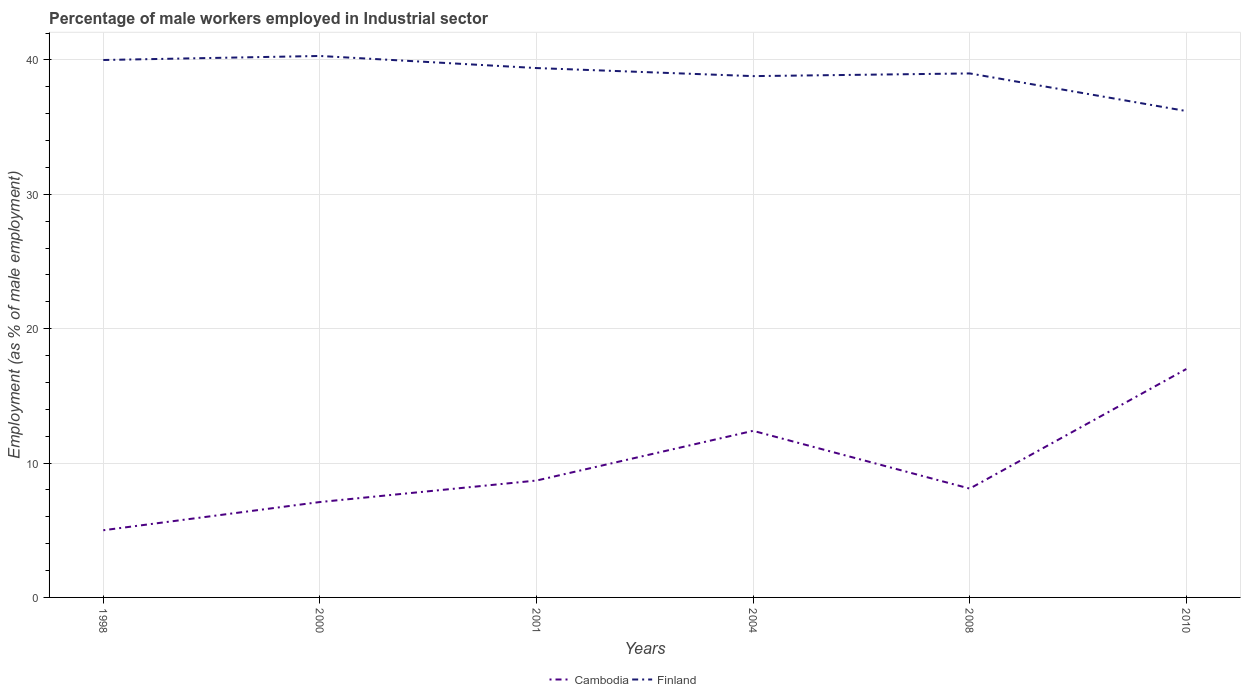Across all years, what is the maximum percentage of male workers employed in Industrial sector in Finland?
Offer a terse response. 36.2. In which year was the percentage of male workers employed in Industrial sector in Cambodia maximum?
Provide a succinct answer. 1998. What is the total percentage of male workers employed in Industrial sector in Cambodia in the graph?
Ensure brevity in your answer.  -3.7. Is the percentage of male workers employed in Industrial sector in Cambodia strictly greater than the percentage of male workers employed in Industrial sector in Finland over the years?
Provide a short and direct response. Yes. How many lines are there?
Offer a very short reply. 2. Are the values on the major ticks of Y-axis written in scientific E-notation?
Your answer should be very brief. No. Does the graph contain grids?
Offer a very short reply. Yes. How many legend labels are there?
Ensure brevity in your answer.  2. How are the legend labels stacked?
Give a very brief answer. Horizontal. What is the title of the graph?
Provide a succinct answer. Percentage of male workers employed in Industrial sector. Does "Argentina" appear as one of the legend labels in the graph?
Make the answer very short. No. What is the label or title of the X-axis?
Keep it short and to the point. Years. What is the label or title of the Y-axis?
Make the answer very short. Employment (as % of male employment). What is the Employment (as % of male employment) in Cambodia in 1998?
Give a very brief answer. 5. What is the Employment (as % of male employment) of Cambodia in 2000?
Offer a terse response. 7.1. What is the Employment (as % of male employment) in Finland in 2000?
Make the answer very short. 40.3. What is the Employment (as % of male employment) in Cambodia in 2001?
Your response must be concise. 8.7. What is the Employment (as % of male employment) in Finland in 2001?
Your answer should be very brief. 39.4. What is the Employment (as % of male employment) in Cambodia in 2004?
Provide a short and direct response. 12.4. What is the Employment (as % of male employment) in Finland in 2004?
Ensure brevity in your answer.  38.8. What is the Employment (as % of male employment) of Cambodia in 2008?
Offer a very short reply. 8.1. What is the Employment (as % of male employment) in Finland in 2008?
Keep it short and to the point. 39. What is the Employment (as % of male employment) in Finland in 2010?
Offer a terse response. 36.2. Across all years, what is the maximum Employment (as % of male employment) of Cambodia?
Keep it short and to the point. 17. Across all years, what is the maximum Employment (as % of male employment) of Finland?
Offer a very short reply. 40.3. Across all years, what is the minimum Employment (as % of male employment) in Finland?
Give a very brief answer. 36.2. What is the total Employment (as % of male employment) in Cambodia in the graph?
Give a very brief answer. 58.3. What is the total Employment (as % of male employment) of Finland in the graph?
Ensure brevity in your answer.  233.7. What is the difference between the Employment (as % of male employment) in Finland in 1998 and that in 2004?
Keep it short and to the point. 1.2. What is the difference between the Employment (as % of male employment) of Cambodia in 1998 and that in 2008?
Offer a very short reply. -3.1. What is the difference between the Employment (as % of male employment) of Cambodia in 1998 and that in 2010?
Offer a very short reply. -12. What is the difference between the Employment (as % of male employment) in Finland in 1998 and that in 2010?
Your answer should be very brief. 3.8. What is the difference between the Employment (as % of male employment) of Cambodia in 2000 and that in 2001?
Offer a terse response. -1.6. What is the difference between the Employment (as % of male employment) in Cambodia in 2000 and that in 2004?
Make the answer very short. -5.3. What is the difference between the Employment (as % of male employment) of Cambodia in 2000 and that in 2008?
Your answer should be compact. -1. What is the difference between the Employment (as % of male employment) in Finland in 2000 and that in 2008?
Give a very brief answer. 1.3. What is the difference between the Employment (as % of male employment) of Cambodia in 2000 and that in 2010?
Your response must be concise. -9.9. What is the difference between the Employment (as % of male employment) of Finland in 2001 and that in 2004?
Offer a very short reply. 0.6. What is the difference between the Employment (as % of male employment) of Cambodia in 2004 and that in 2010?
Make the answer very short. -4.6. What is the difference between the Employment (as % of male employment) in Finland in 2004 and that in 2010?
Provide a succinct answer. 2.6. What is the difference between the Employment (as % of male employment) of Cambodia in 2008 and that in 2010?
Give a very brief answer. -8.9. What is the difference between the Employment (as % of male employment) of Finland in 2008 and that in 2010?
Your response must be concise. 2.8. What is the difference between the Employment (as % of male employment) in Cambodia in 1998 and the Employment (as % of male employment) in Finland in 2000?
Keep it short and to the point. -35.3. What is the difference between the Employment (as % of male employment) in Cambodia in 1998 and the Employment (as % of male employment) in Finland in 2001?
Make the answer very short. -34.4. What is the difference between the Employment (as % of male employment) of Cambodia in 1998 and the Employment (as % of male employment) of Finland in 2004?
Offer a terse response. -33.8. What is the difference between the Employment (as % of male employment) of Cambodia in 1998 and the Employment (as % of male employment) of Finland in 2008?
Make the answer very short. -34. What is the difference between the Employment (as % of male employment) of Cambodia in 1998 and the Employment (as % of male employment) of Finland in 2010?
Offer a terse response. -31.2. What is the difference between the Employment (as % of male employment) of Cambodia in 2000 and the Employment (as % of male employment) of Finland in 2001?
Your answer should be very brief. -32.3. What is the difference between the Employment (as % of male employment) in Cambodia in 2000 and the Employment (as % of male employment) in Finland in 2004?
Your answer should be compact. -31.7. What is the difference between the Employment (as % of male employment) in Cambodia in 2000 and the Employment (as % of male employment) in Finland in 2008?
Provide a succinct answer. -31.9. What is the difference between the Employment (as % of male employment) of Cambodia in 2000 and the Employment (as % of male employment) of Finland in 2010?
Offer a terse response. -29.1. What is the difference between the Employment (as % of male employment) of Cambodia in 2001 and the Employment (as % of male employment) of Finland in 2004?
Keep it short and to the point. -30.1. What is the difference between the Employment (as % of male employment) in Cambodia in 2001 and the Employment (as % of male employment) in Finland in 2008?
Keep it short and to the point. -30.3. What is the difference between the Employment (as % of male employment) in Cambodia in 2001 and the Employment (as % of male employment) in Finland in 2010?
Make the answer very short. -27.5. What is the difference between the Employment (as % of male employment) in Cambodia in 2004 and the Employment (as % of male employment) in Finland in 2008?
Your answer should be compact. -26.6. What is the difference between the Employment (as % of male employment) in Cambodia in 2004 and the Employment (as % of male employment) in Finland in 2010?
Give a very brief answer. -23.8. What is the difference between the Employment (as % of male employment) in Cambodia in 2008 and the Employment (as % of male employment) in Finland in 2010?
Ensure brevity in your answer.  -28.1. What is the average Employment (as % of male employment) of Cambodia per year?
Give a very brief answer. 9.72. What is the average Employment (as % of male employment) in Finland per year?
Your response must be concise. 38.95. In the year 1998, what is the difference between the Employment (as % of male employment) of Cambodia and Employment (as % of male employment) of Finland?
Provide a succinct answer. -35. In the year 2000, what is the difference between the Employment (as % of male employment) of Cambodia and Employment (as % of male employment) of Finland?
Your answer should be compact. -33.2. In the year 2001, what is the difference between the Employment (as % of male employment) in Cambodia and Employment (as % of male employment) in Finland?
Offer a very short reply. -30.7. In the year 2004, what is the difference between the Employment (as % of male employment) of Cambodia and Employment (as % of male employment) of Finland?
Offer a terse response. -26.4. In the year 2008, what is the difference between the Employment (as % of male employment) in Cambodia and Employment (as % of male employment) in Finland?
Offer a terse response. -30.9. In the year 2010, what is the difference between the Employment (as % of male employment) of Cambodia and Employment (as % of male employment) of Finland?
Keep it short and to the point. -19.2. What is the ratio of the Employment (as % of male employment) in Cambodia in 1998 to that in 2000?
Make the answer very short. 0.7. What is the ratio of the Employment (as % of male employment) in Cambodia in 1998 to that in 2001?
Your answer should be very brief. 0.57. What is the ratio of the Employment (as % of male employment) of Finland in 1998 to that in 2001?
Offer a very short reply. 1.02. What is the ratio of the Employment (as % of male employment) of Cambodia in 1998 to that in 2004?
Provide a short and direct response. 0.4. What is the ratio of the Employment (as % of male employment) of Finland in 1998 to that in 2004?
Offer a very short reply. 1.03. What is the ratio of the Employment (as % of male employment) in Cambodia in 1998 to that in 2008?
Ensure brevity in your answer.  0.62. What is the ratio of the Employment (as % of male employment) in Finland in 1998 to that in 2008?
Ensure brevity in your answer.  1.03. What is the ratio of the Employment (as % of male employment) in Cambodia in 1998 to that in 2010?
Give a very brief answer. 0.29. What is the ratio of the Employment (as % of male employment) of Finland in 1998 to that in 2010?
Give a very brief answer. 1.1. What is the ratio of the Employment (as % of male employment) in Cambodia in 2000 to that in 2001?
Your answer should be compact. 0.82. What is the ratio of the Employment (as % of male employment) in Finland in 2000 to that in 2001?
Your response must be concise. 1.02. What is the ratio of the Employment (as % of male employment) in Cambodia in 2000 to that in 2004?
Ensure brevity in your answer.  0.57. What is the ratio of the Employment (as % of male employment) of Finland in 2000 to that in 2004?
Provide a short and direct response. 1.04. What is the ratio of the Employment (as % of male employment) in Cambodia in 2000 to that in 2008?
Your answer should be very brief. 0.88. What is the ratio of the Employment (as % of male employment) of Cambodia in 2000 to that in 2010?
Offer a very short reply. 0.42. What is the ratio of the Employment (as % of male employment) of Finland in 2000 to that in 2010?
Ensure brevity in your answer.  1.11. What is the ratio of the Employment (as % of male employment) of Cambodia in 2001 to that in 2004?
Your answer should be compact. 0.7. What is the ratio of the Employment (as % of male employment) of Finland in 2001 to that in 2004?
Provide a succinct answer. 1.02. What is the ratio of the Employment (as % of male employment) in Cambodia in 2001 to that in 2008?
Offer a very short reply. 1.07. What is the ratio of the Employment (as % of male employment) in Finland in 2001 to that in 2008?
Your answer should be compact. 1.01. What is the ratio of the Employment (as % of male employment) in Cambodia in 2001 to that in 2010?
Ensure brevity in your answer.  0.51. What is the ratio of the Employment (as % of male employment) of Finland in 2001 to that in 2010?
Provide a succinct answer. 1.09. What is the ratio of the Employment (as % of male employment) in Cambodia in 2004 to that in 2008?
Your answer should be compact. 1.53. What is the ratio of the Employment (as % of male employment) of Cambodia in 2004 to that in 2010?
Make the answer very short. 0.73. What is the ratio of the Employment (as % of male employment) of Finland in 2004 to that in 2010?
Provide a succinct answer. 1.07. What is the ratio of the Employment (as % of male employment) of Cambodia in 2008 to that in 2010?
Provide a succinct answer. 0.48. What is the ratio of the Employment (as % of male employment) in Finland in 2008 to that in 2010?
Your answer should be compact. 1.08. What is the difference between the highest and the second highest Employment (as % of male employment) of Cambodia?
Offer a very short reply. 4.6. What is the difference between the highest and the second highest Employment (as % of male employment) of Finland?
Keep it short and to the point. 0.3. What is the difference between the highest and the lowest Employment (as % of male employment) of Cambodia?
Make the answer very short. 12. What is the difference between the highest and the lowest Employment (as % of male employment) of Finland?
Offer a terse response. 4.1. 